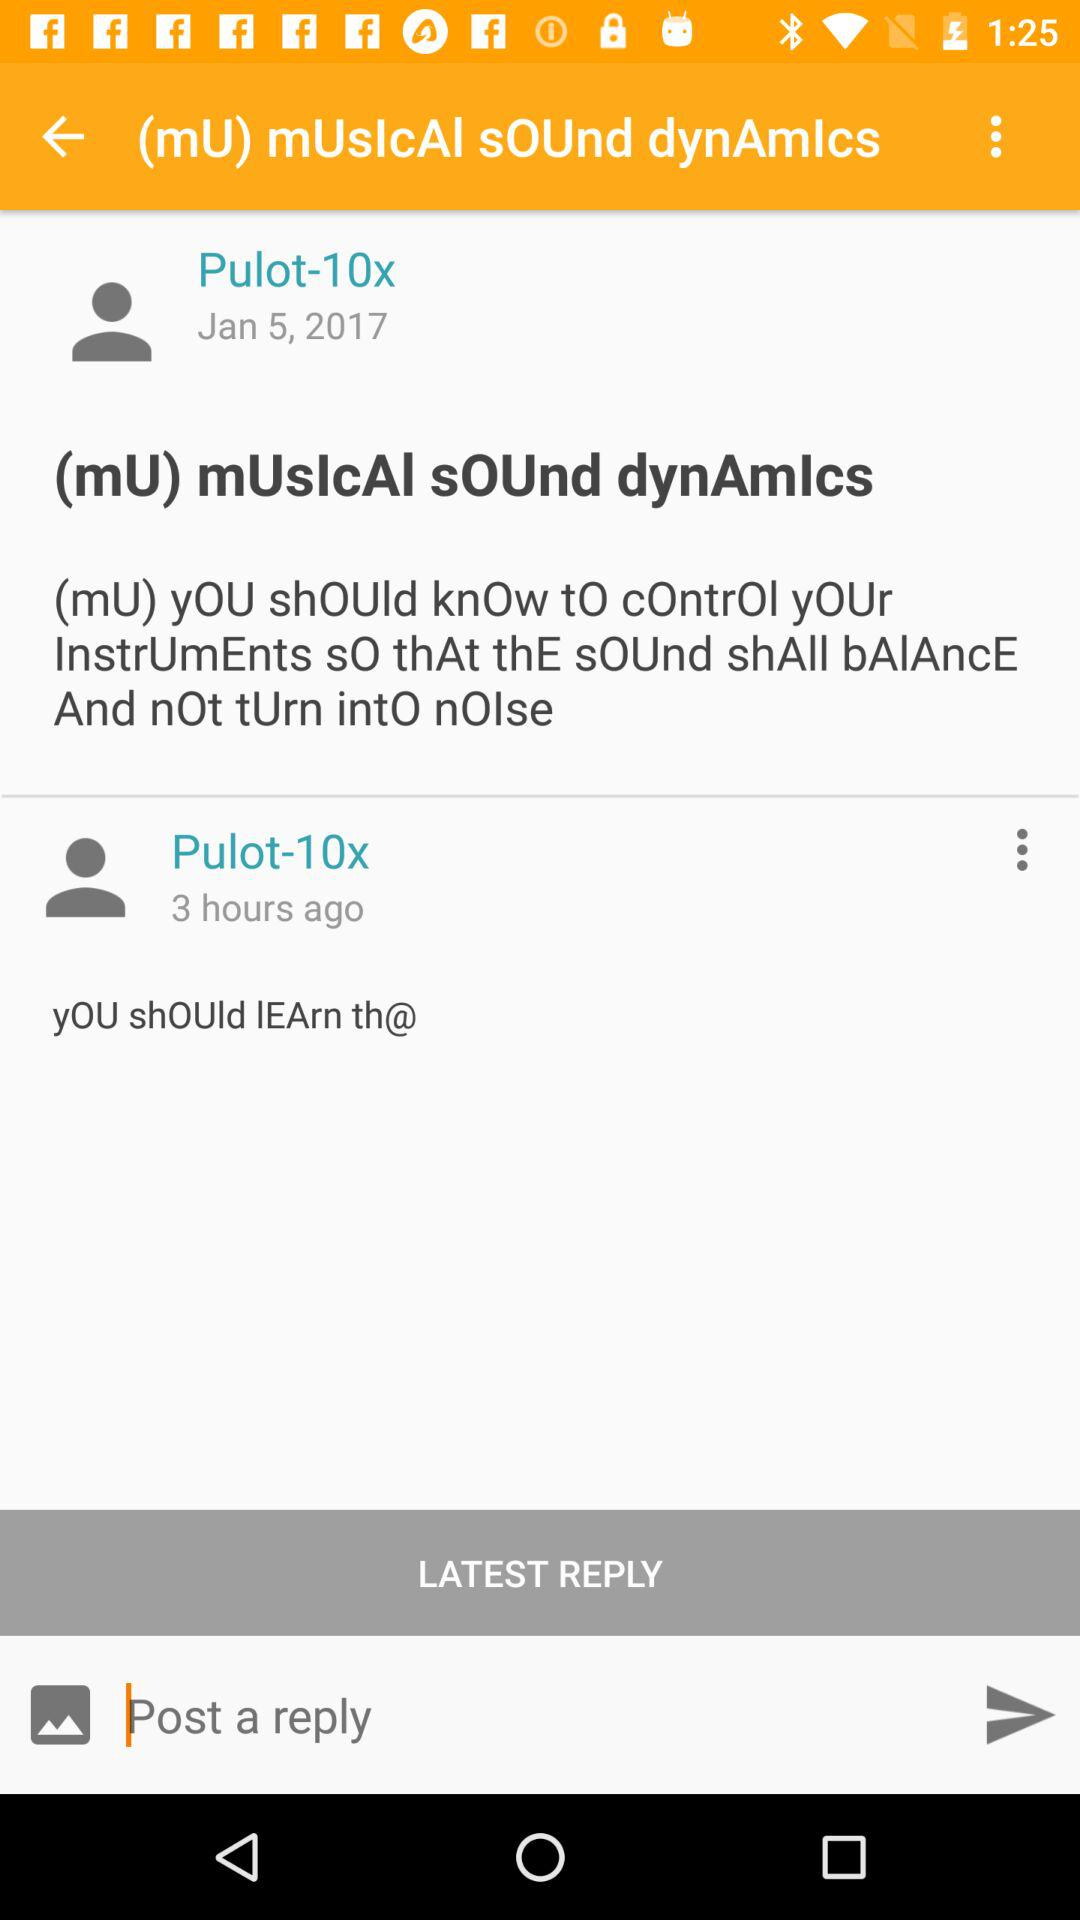How many hours ago was the latest reply posted?
Answer the question using a single word or phrase. 3 hours ago 